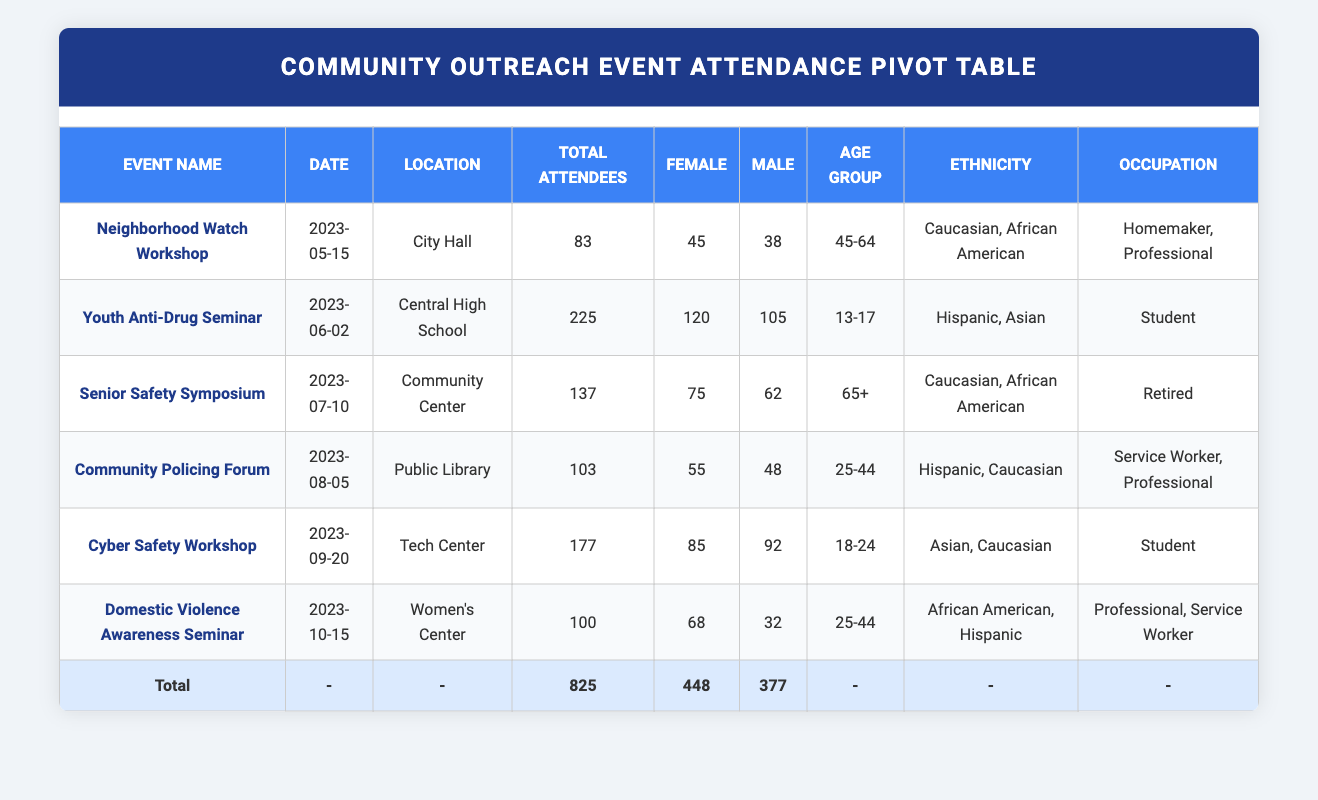What is the total number of attendees at the Youth Anti-Drug Seminar? The table shows the Youth Anti-Drug Seminar had a total of 225 attendees, combining both male and female participants.
Answer: 225 Which event had the highest female attendance? Looking at the table, the Youth Anti-Drug Seminar had the highest female attendance with 120 attendees.
Answer: 120 Is there more male or female attendance at the Domestic Violence Awareness Seminar? The table shows that there were 68 female attendees and 32 male attendees at this seminar. Since 68 is greater than 32, there are more females involved.
Answer: Yes What was the average number of attendees across all events? To find the average, we add the total attendees (825) and divide by the number of events (6). Calculating gives us 825/6, which equals 137.5.
Answer: 137.5 How many attendees were aged 65 and older across all events? In the Senior Safety Symposium, there were 75 female and 62 male attendees, totaling 137 attendees in the age group of 65 and older.
Answer: 137 What is the total male attendance across all events? The male attendees per event are 38 (Neighborhood Watch), 105 (Youth Anti-Drug), 62 (Senior Safety), 48 (Community Policing), 92 (Cyber Safety), and 32 (Domestic Violence), summing them gives 38 + 105 + 62 + 48 + 92 + 32 = 377.
Answer: 377 Are any occupations represented more than once among the attendees? By examining the table, we can see "Professional" appears in both the Neighborhood Watch Workshop and Domestic Violence Awareness Seminar, indicating multiple occurrences of this occupation.
Answer: Yes Which event had the lowest total attendance? The Community Policing Forum had 103 attendees, which is lower than the total of any other event indicated in the table.
Answer: 103 